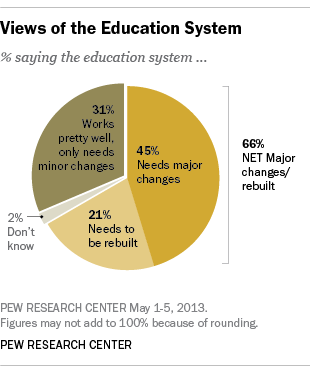Point out several critical features in this image. The most widely held view is that major modifications are required. According to a recent survey, 0.66% of people believe that the current healthcare system in the United States needs significant change or rebuilding. 